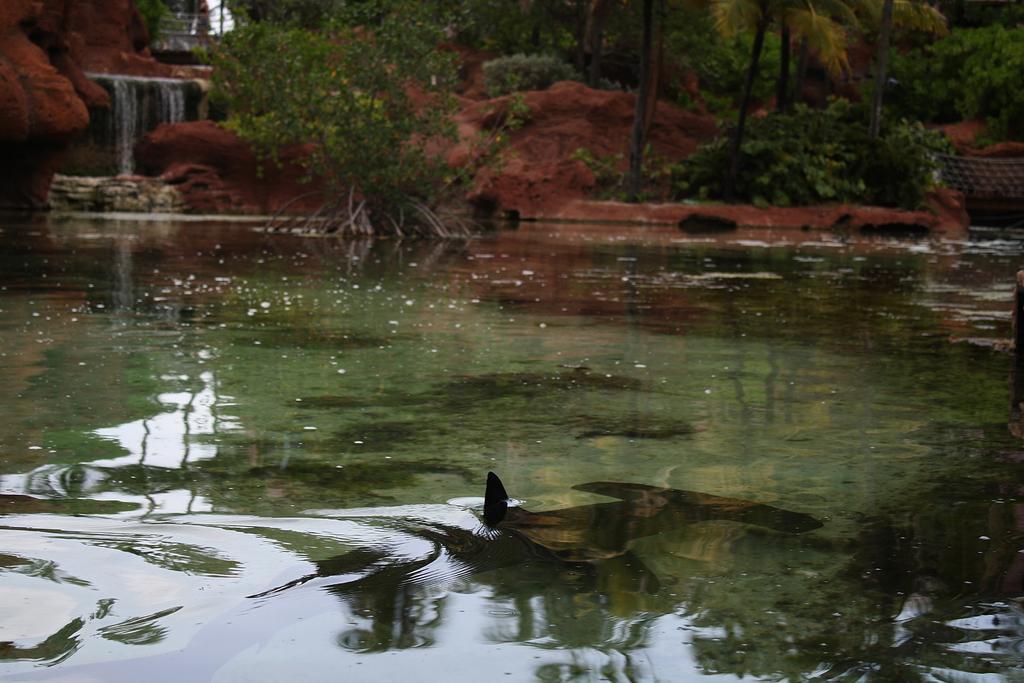How would you summarize this image in a sentence or two? There is water. In the water there is fish. In the background there are trees, small waterfall and soil. 